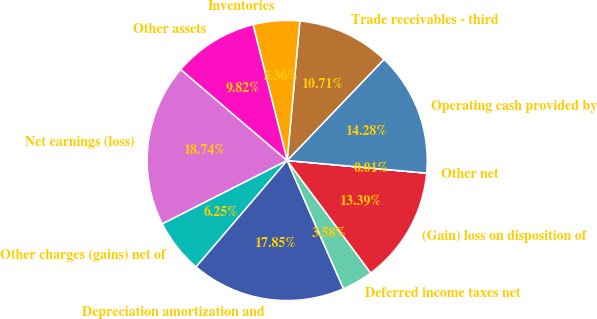Convert chart to OTSL. <chart><loc_0><loc_0><loc_500><loc_500><pie_chart><fcel>Net earnings (loss)<fcel>Other charges (gains) net of<fcel>Depreciation amortization and<fcel>Deferred income taxes net<fcel>(Gain) loss on disposition of<fcel>Other net<fcel>Operating cash provided by<fcel>Trade receivables - third<fcel>Inventories<fcel>Other assets<nl><fcel>18.74%<fcel>6.25%<fcel>17.85%<fcel>3.58%<fcel>13.39%<fcel>0.01%<fcel>14.28%<fcel>10.71%<fcel>5.36%<fcel>9.82%<nl></chart> 